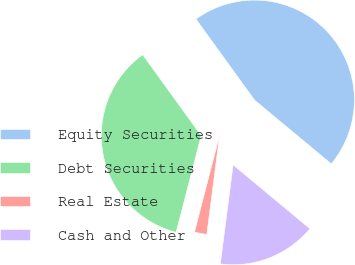Convert chart. <chart><loc_0><loc_0><loc_500><loc_500><pie_chart><fcel>Equity Securities<fcel>Debt Securities<fcel>Real Estate<fcel>Cash and Other<nl><fcel>46.0%<fcel>36.0%<fcel>2.0%<fcel>16.0%<nl></chart> 